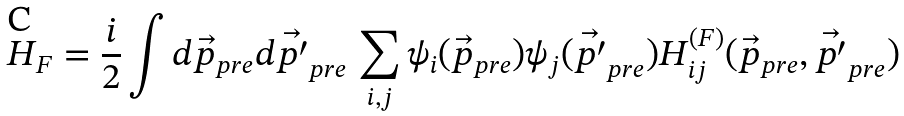Convert formula to latex. <formula><loc_0><loc_0><loc_500><loc_500>H _ { F } = \frac { i } { 2 } \int d \vec { p } _ { p r e } d \vec { p ^ { \prime } } _ { p r e } \, \sum _ { i , j } \psi _ { i } ( \vec { p } _ { p r e } ) \psi _ { j } ( \vec { p ^ { \prime } } _ { p r e } ) H _ { i j } ^ { ( F ) } ( \vec { p } _ { p r e } , \vec { p ^ { \prime } } _ { p r e } )</formula> 